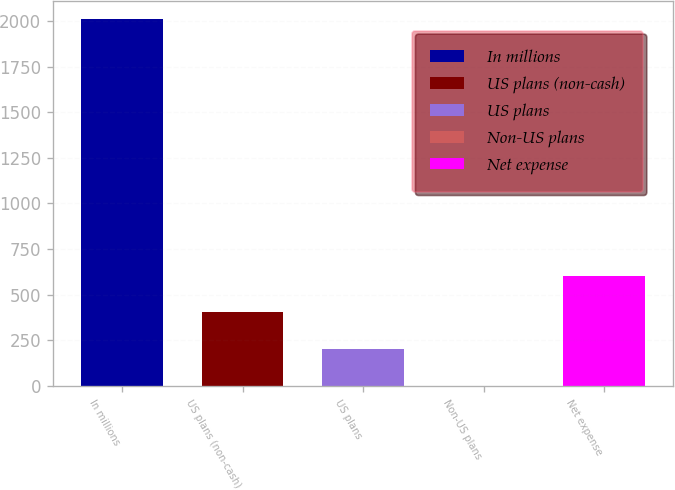Convert chart. <chart><loc_0><loc_0><loc_500><loc_500><bar_chart><fcel>In millions<fcel>US plans (non-cash)<fcel>US plans<fcel>Non-US plans<fcel>Net expense<nl><fcel>2010<fcel>402.8<fcel>201.9<fcel>1<fcel>603.7<nl></chart> 